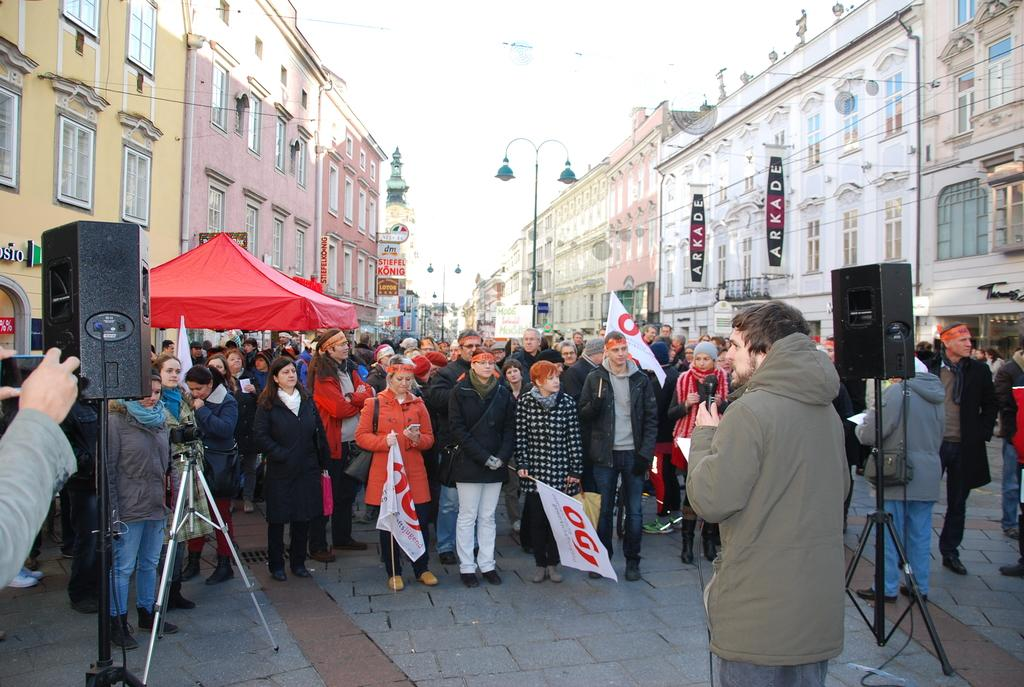What can be seen in the image in terms of people? There are groups of people in the image. What objects are related to sound in the image? There are sound boxes in the image. What type of signage is present in the image? There are banners in the image. What type of temporary shelter is visible in the image? There is a tent in the image. What type of structures can be seen in the background of the image? There are buildings in the image. What type of lighting is present in the image? There are street lamps in the image. What part of the natural environment is visible in the image? The sky is visible in the image. What type of shirt is being worn by the wine in the image? There is no wine or shirt present in the image. How many kisses are visible on the banners in the image? There are no kisses depicted on the banners in the image. 